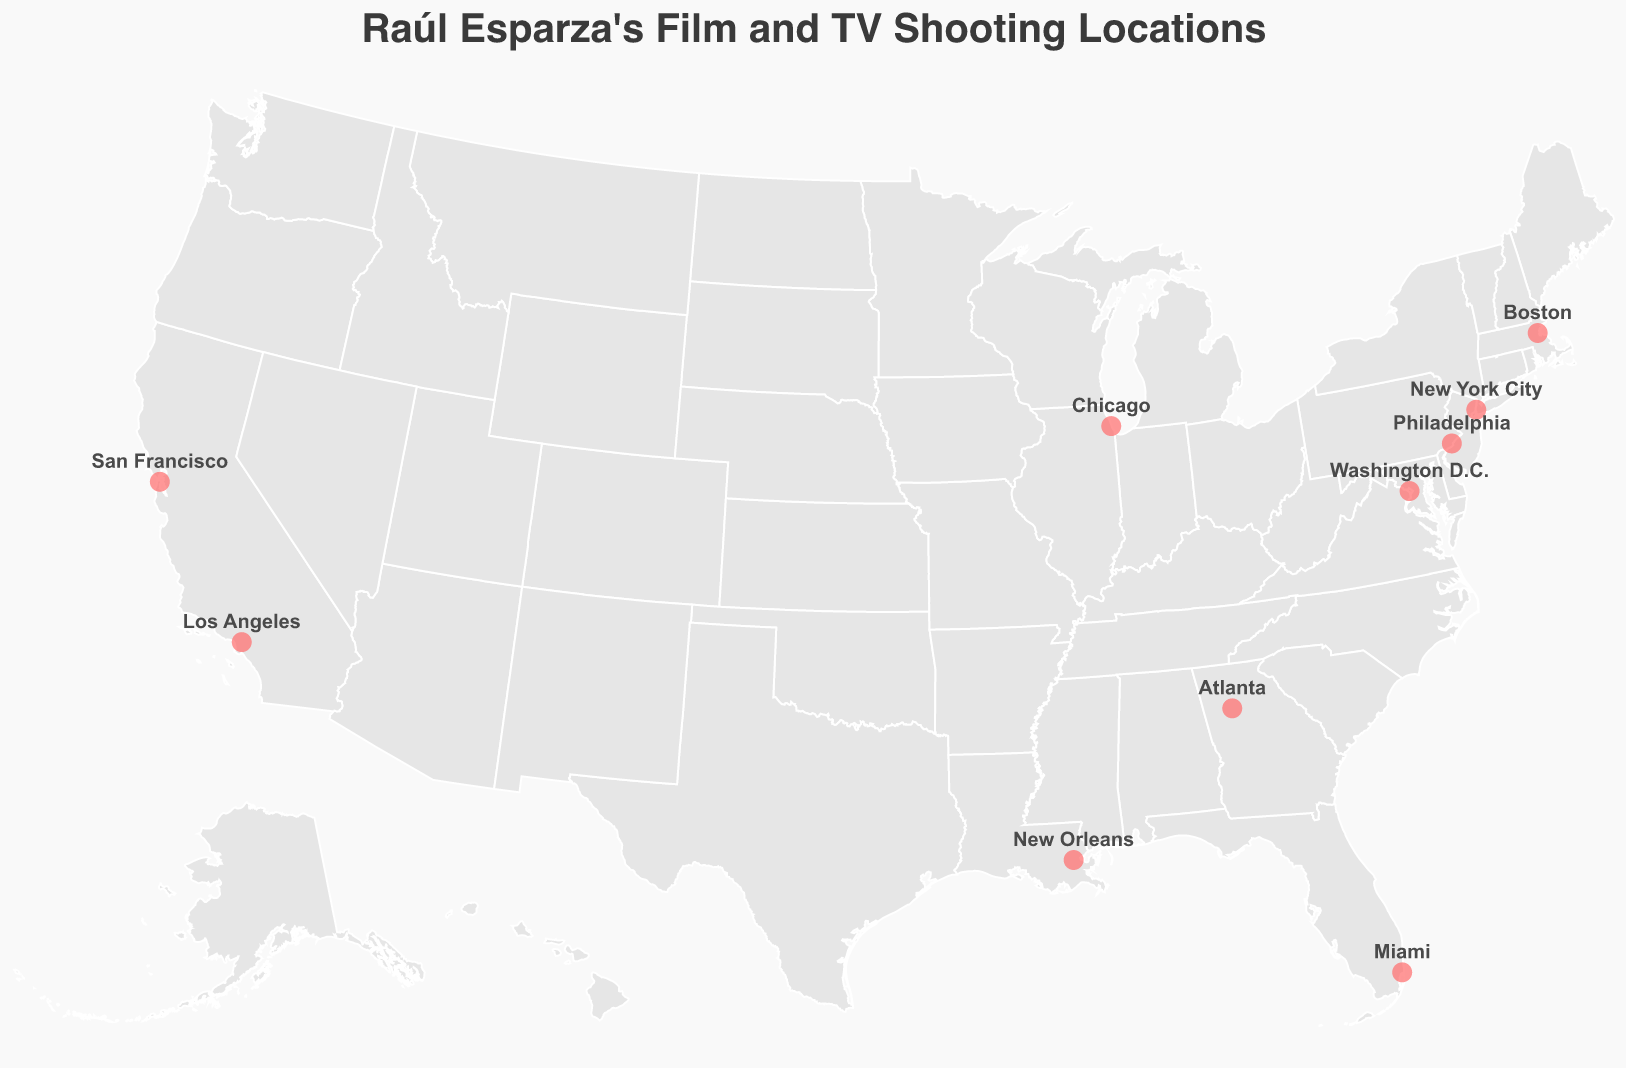What's the title of the figure? The title is prominently displayed at the top of the figure.
Answer: Raúl Esparza's Film and TV Shooting Locations How many shooting locations are marked on the map? Count the number of circle markers on the map. Each circle represents a shooting location.
Answer: 10 Which city in California did Raúl Esparza have shooting locations? Identify the cities listed in California by checking their latitude and longitude positions marked on the state.
Answer: Los Angeles and San Francisco In which city did Raúl Esparza shoot for the project "Hannibal"? Hover over the markers to find the tooltip that mentions the project "Hannibal" along with its corresponding city.
Answer: Miami Which cities had shooting locations in the year 2016? Identify the markers that, when hovered over, show the tooltip with the year 2016.
Answer: Washington D.C. and New Orleans Which city had the earliest shooting year and what is the project name? Look for the marker with the earliest year in the tooltip and note the project name associated with it.
Answer: Boston, Find Me Guilty Is there any state with more than one shooting location? Check the state names on the map near the markers to see if more than one project is listed for the same state.
Answer: California What is the geographic coordinate of the shooting location for "Chicago P.D."? Hover over the marker for Chicago and check the latitude and longitude in the tooltip.
Answer: 41.8781, -87.6298 Which shooting locations are in cities with a latitude higher than 40? Identify the markers with cities having latitude values greater than 40, as seen in the tooltips.
Answer: New York City, Chicago, Boston Between Miami and New York City, which shooting location is further east? Compare the longitude values of Miami and New York City. The city with the lower longitude value is further east.
Answer: New York City 